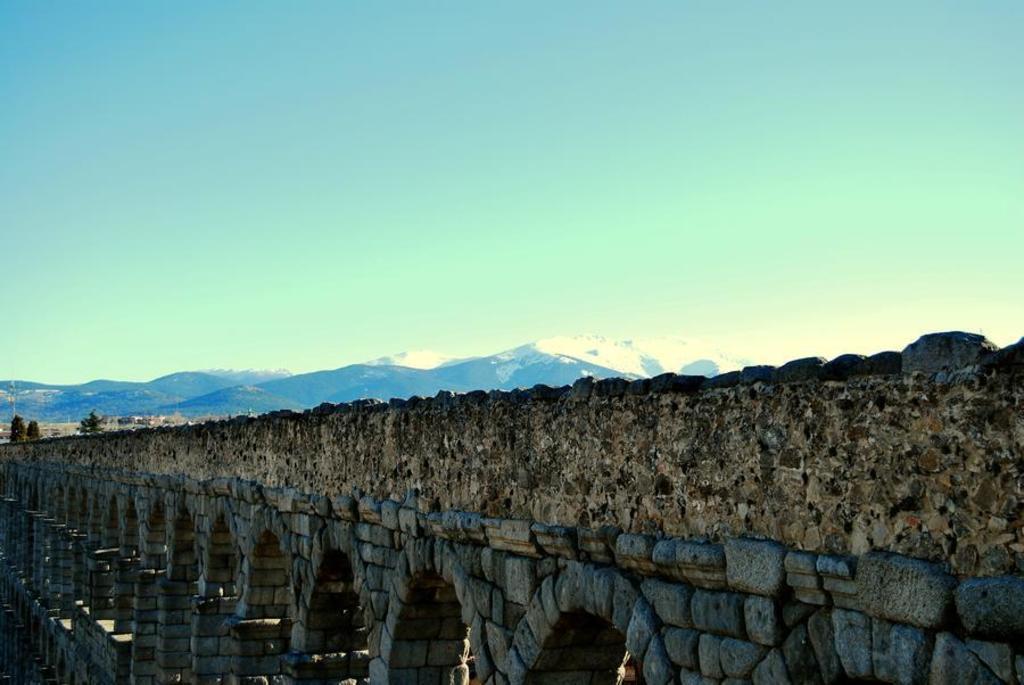Could you give a brief overview of what you see in this image? In this image I can see the fort, background I can see mountains and the sky is in blue color. 